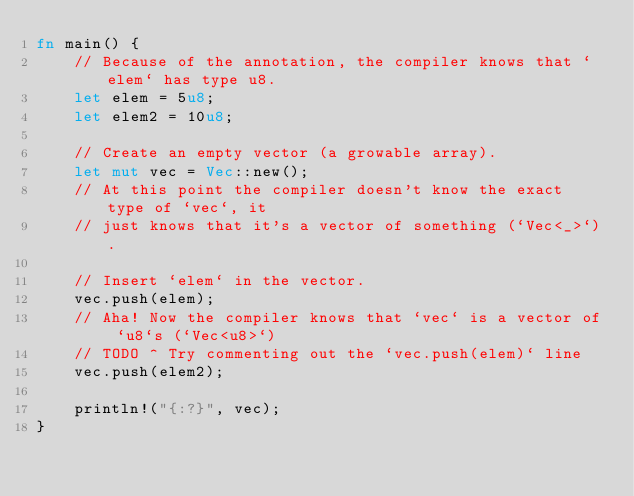Convert code to text. <code><loc_0><loc_0><loc_500><loc_500><_Rust_>fn main() {
    // Because of the annotation, the compiler knows that `elem` has type u8.
    let elem = 5u8;
    let elem2 = 10u8;

    // Create an empty vector (a growable array).
    let mut vec = Vec::new();
    // At this point the compiler doesn't know the exact type of `vec`, it
    // just knows that it's a vector of something (`Vec<_>`).

    // Insert `elem` in the vector.
    vec.push(elem);
    // Aha! Now the compiler knows that `vec` is a vector of `u8`s (`Vec<u8>`)
    // TODO ^ Try commenting out the `vec.push(elem)` line
    vec.push(elem2);

    println!("{:?}", vec);
}
</code> 